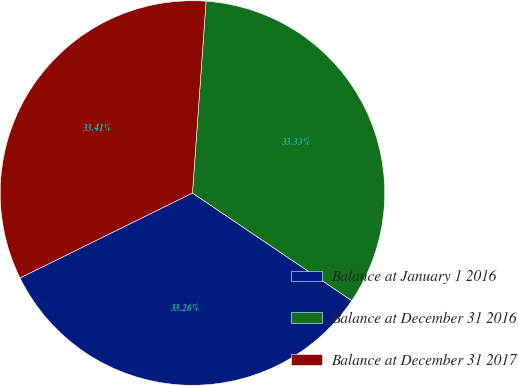Convert chart. <chart><loc_0><loc_0><loc_500><loc_500><pie_chart><fcel>Balance at January 1 2016<fcel>Balance at December 31 2016<fcel>Balance at December 31 2017<nl><fcel>33.26%<fcel>33.33%<fcel>33.41%<nl></chart> 